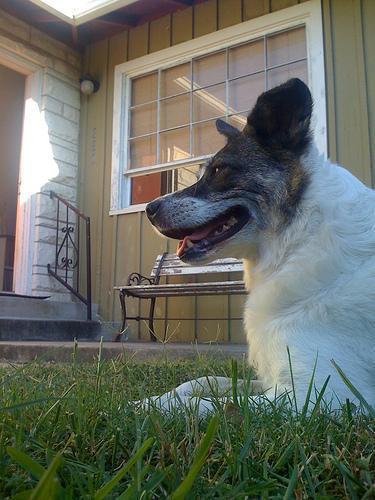How many dogs are in this scene?
Give a very brief answer. 1. How many birds are standing in the pizza box?
Give a very brief answer. 0. 